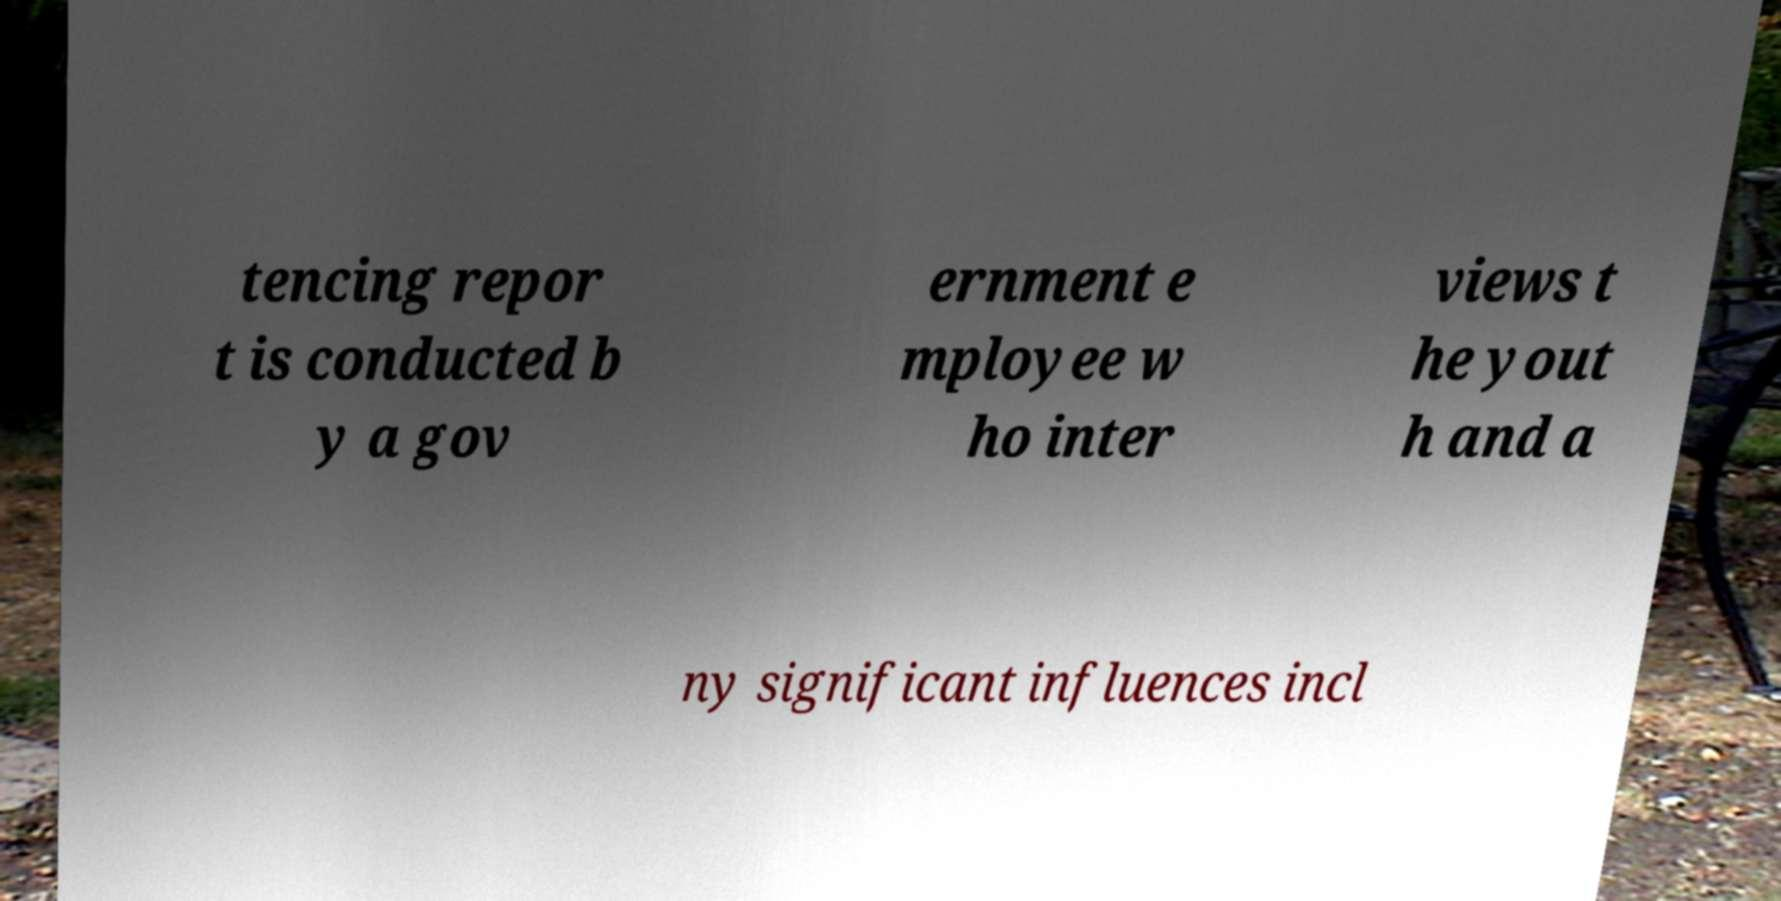Please identify and transcribe the text found in this image. tencing repor t is conducted b y a gov ernment e mployee w ho inter views t he yout h and a ny significant influences incl 